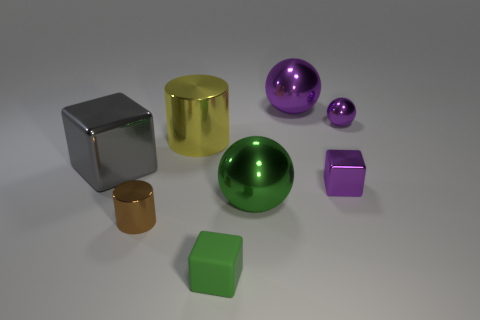Subtract all metal cubes. How many cubes are left? 1 Subtract all red cubes. How many purple balls are left? 2 Add 2 red matte balls. How many objects exist? 10 Subtract 1 spheres. How many spheres are left? 2 Subtract all balls. How many objects are left? 5 Add 5 big balls. How many big balls are left? 7 Add 8 purple matte cylinders. How many purple matte cylinders exist? 8 Subtract 0 red spheres. How many objects are left? 8 Subtract all purple cylinders. Subtract all brown balls. How many cylinders are left? 2 Subtract all metal blocks. Subtract all tiny green blocks. How many objects are left? 5 